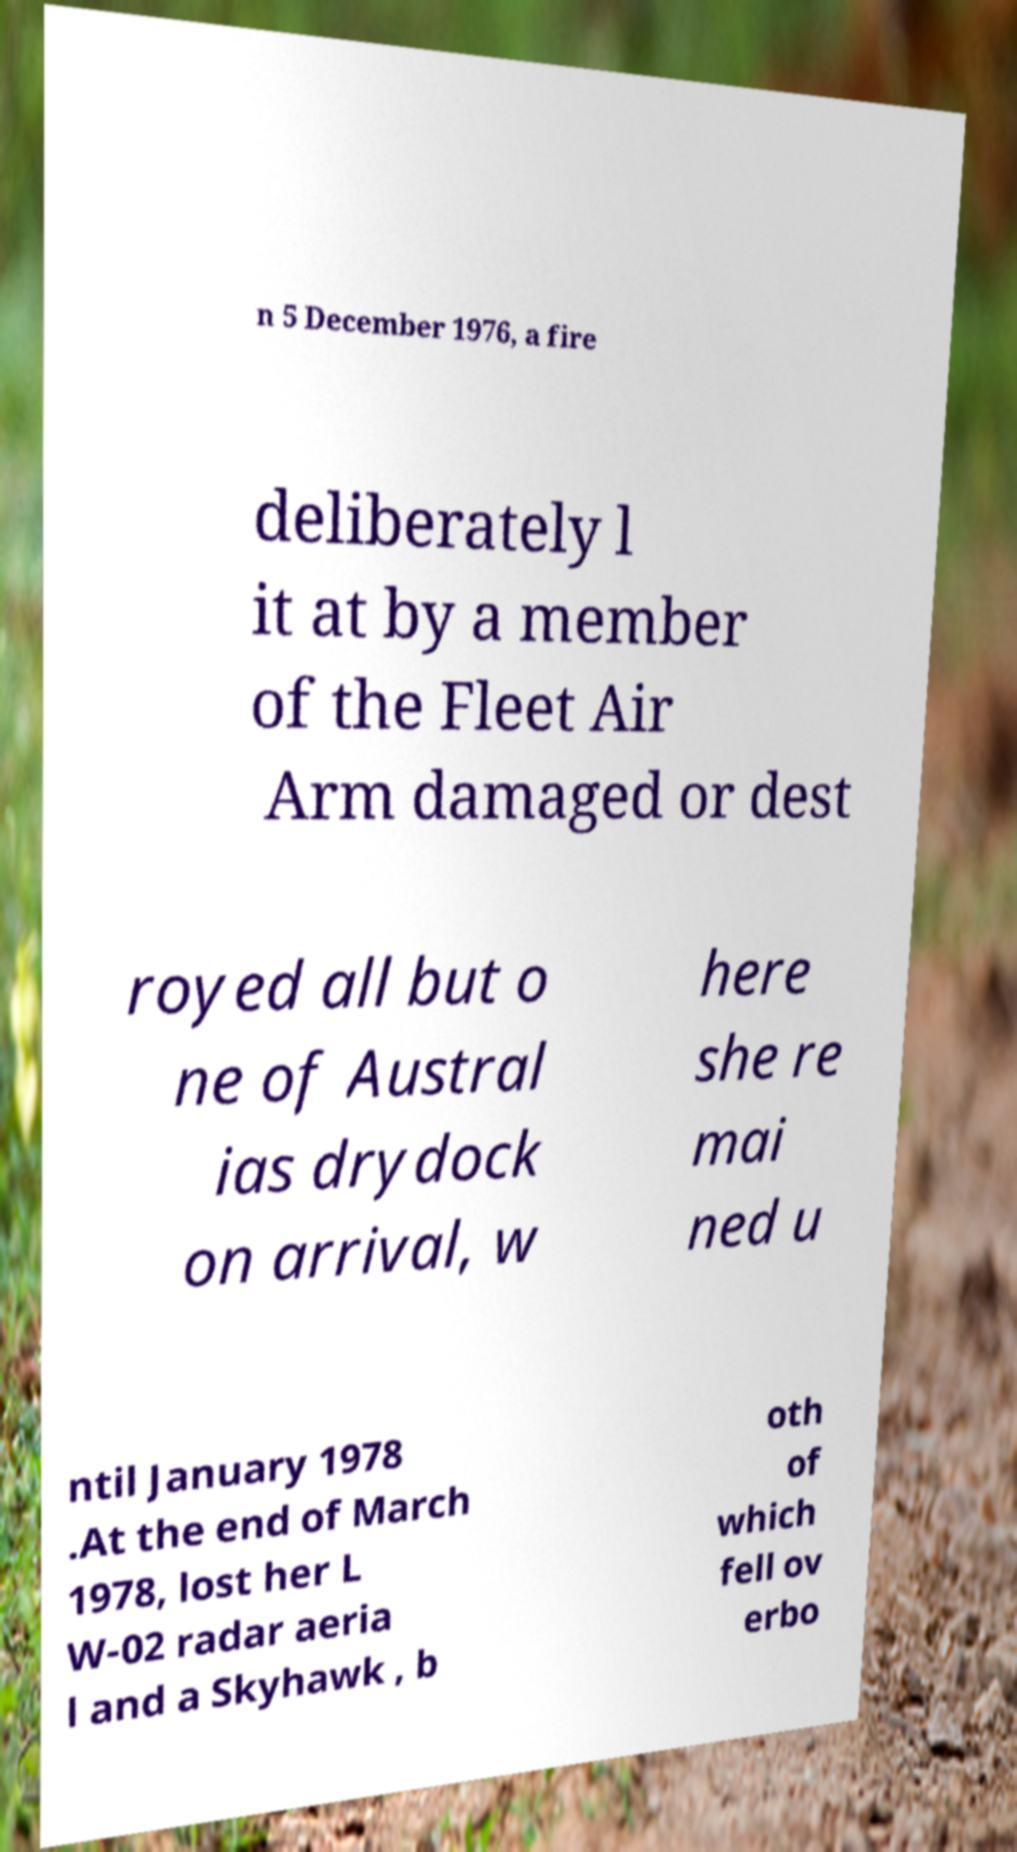Can you read and provide the text displayed in the image?This photo seems to have some interesting text. Can you extract and type it out for me? n 5 December 1976, a fire deliberately l it at by a member of the Fleet Air Arm damaged or dest royed all but o ne of Austral ias drydock on arrival, w here she re mai ned u ntil January 1978 .At the end of March 1978, lost her L W-02 radar aeria l and a Skyhawk , b oth of which fell ov erbo 